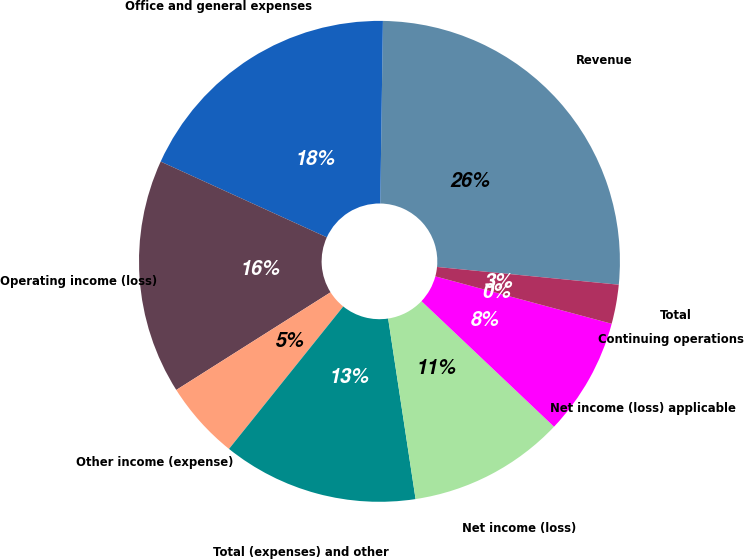<chart> <loc_0><loc_0><loc_500><loc_500><pie_chart><fcel>Revenue<fcel>Office and general expenses<fcel>Operating income (loss)<fcel>Other income (expense)<fcel>Total (expenses) and other<fcel>Net income (loss)<fcel>Net income (loss) applicable<fcel>Continuing operations<fcel>Total<nl><fcel>26.32%<fcel>18.42%<fcel>15.79%<fcel>5.26%<fcel>13.16%<fcel>10.53%<fcel>7.89%<fcel>0.0%<fcel>2.63%<nl></chart> 